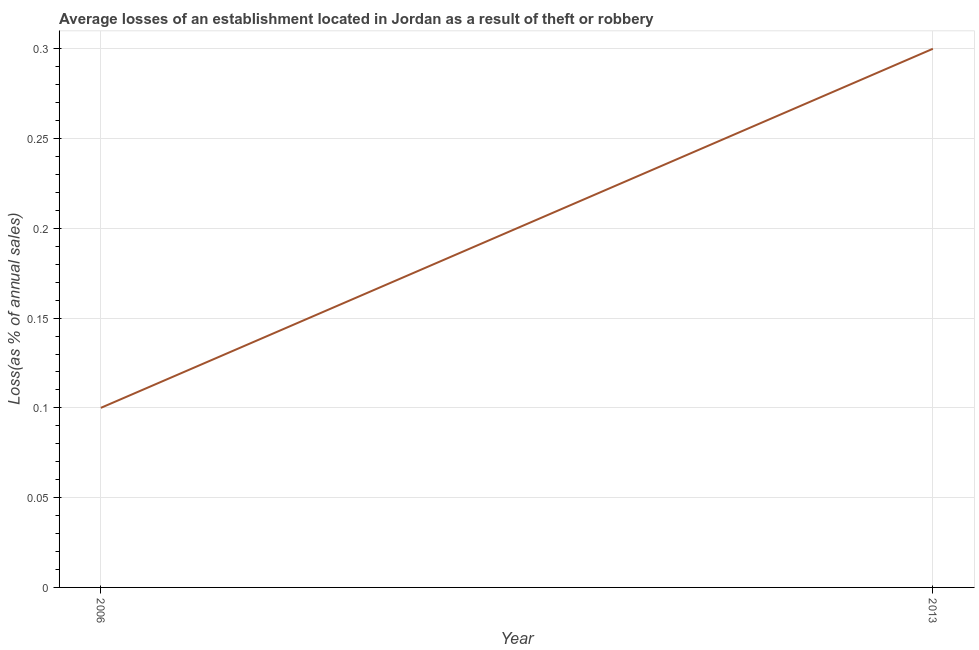Across all years, what is the minimum losses due to theft?
Your answer should be very brief. 0.1. What is the sum of the losses due to theft?
Your answer should be very brief. 0.4. What is the difference between the losses due to theft in 2006 and 2013?
Give a very brief answer. -0.2. What is the average losses due to theft per year?
Give a very brief answer. 0.2. What is the median losses due to theft?
Provide a short and direct response. 0.2. What is the ratio of the losses due to theft in 2006 to that in 2013?
Your answer should be compact. 0.33. Is the losses due to theft in 2006 less than that in 2013?
Give a very brief answer. Yes. How many lines are there?
Make the answer very short. 1. How many years are there in the graph?
Ensure brevity in your answer.  2. What is the difference between two consecutive major ticks on the Y-axis?
Ensure brevity in your answer.  0.05. Does the graph contain any zero values?
Keep it short and to the point. No. Does the graph contain grids?
Make the answer very short. Yes. What is the title of the graph?
Make the answer very short. Average losses of an establishment located in Jordan as a result of theft or robbery. What is the label or title of the Y-axis?
Your answer should be compact. Loss(as % of annual sales). What is the Loss(as % of annual sales) in 2006?
Your response must be concise. 0.1. What is the difference between the Loss(as % of annual sales) in 2006 and 2013?
Offer a very short reply. -0.2. What is the ratio of the Loss(as % of annual sales) in 2006 to that in 2013?
Ensure brevity in your answer.  0.33. 